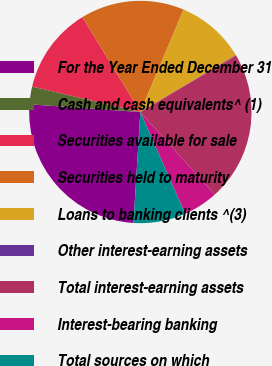<chart> <loc_0><loc_0><loc_500><loc_500><pie_chart><fcel>For the Year Ended December 31<fcel>Cash and cash equivalents^ (1)<fcel>Securities available for sale<fcel>Securities held to maturity<fcel>Loans to banking clients ^(3)<fcel>Other interest-earning assets<fcel>Total interest-earning assets<fcel>Interest-bearing banking<fcel>Total sources on which<nl><fcel>25.11%<fcel>2.58%<fcel>12.59%<fcel>15.09%<fcel>10.09%<fcel>0.07%<fcel>21.8%<fcel>5.08%<fcel>7.58%<nl></chart> 